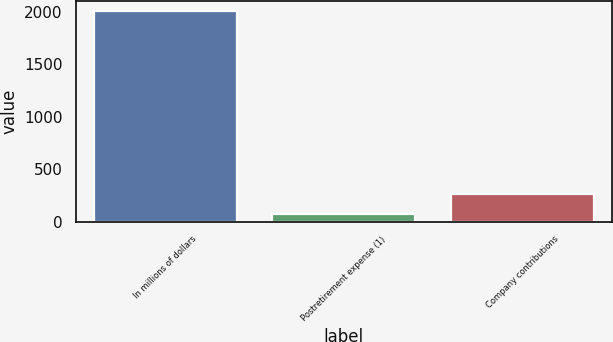Convert chart. <chart><loc_0><loc_0><loc_500><loc_500><bar_chart><fcel>In millions of dollars<fcel>Postretirement expense (1)<fcel>Company contributions<nl><fcel>2007<fcel>69<fcel>262.8<nl></chart> 